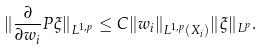<formula> <loc_0><loc_0><loc_500><loc_500>\| \frac { \partial } { \partial w _ { i } } P \xi \| _ { L ^ { 1 , p } } \leq C \| w _ { i } \| _ { L ^ { 1 , p } ( X _ { i } ) } \| \xi \| _ { L ^ { p } } .</formula> 